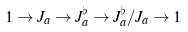<formula> <loc_0><loc_0><loc_500><loc_500>1 \rightarrow J _ { a } \rightarrow J _ { a } ^ { \flat } \rightarrow J _ { a } ^ { \flat } / J _ { a } \rightarrow 1</formula> 